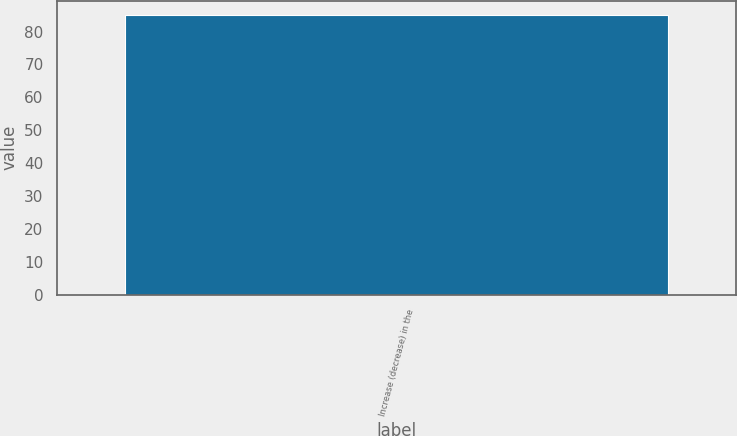Convert chart. <chart><loc_0><loc_0><loc_500><loc_500><bar_chart><fcel>Increase (decrease) in the<nl><fcel>85<nl></chart> 